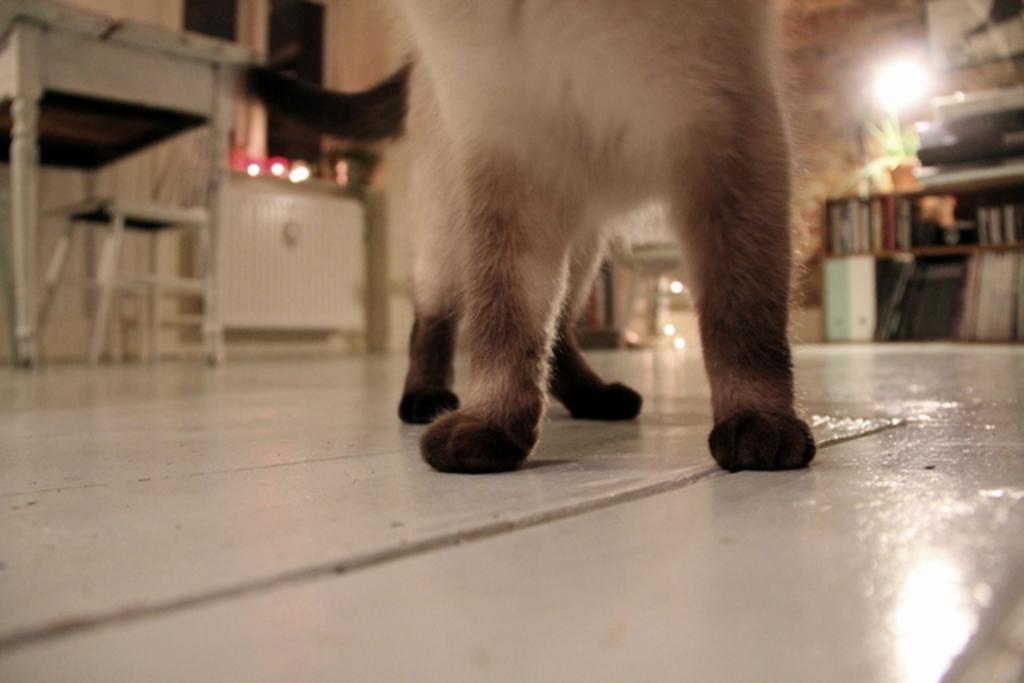How would you summarize this image in a sentence or two? In this image, this looks like an animal standing on the floor. This is a table and a chair. I think this is a cupboard. These are the books, which are placed in a bookshelf. I can see few objects near the window. 